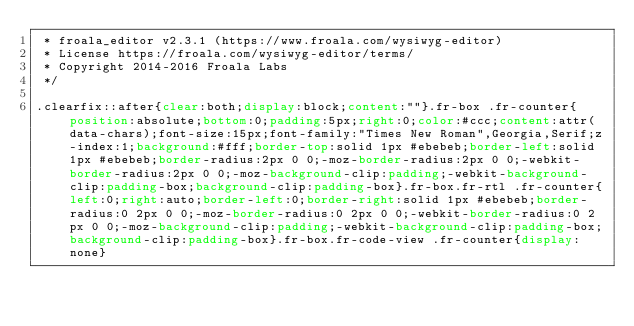<code> <loc_0><loc_0><loc_500><loc_500><_CSS_> * froala_editor v2.3.1 (https://www.froala.com/wysiwyg-editor)
 * License https://froala.com/wysiwyg-editor/terms/
 * Copyright 2014-2016 Froala Labs
 */

.clearfix::after{clear:both;display:block;content:""}.fr-box .fr-counter{position:absolute;bottom:0;padding:5px;right:0;color:#ccc;content:attr(data-chars);font-size:15px;font-family:"Times New Roman",Georgia,Serif;z-index:1;background:#fff;border-top:solid 1px #ebebeb;border-left:solid 1px #ebebeb;border-radius:2px 0 0;-moz-border-radius:2px 0 0;-webkit-border-radius:2px 0 0;-moz-background-clip:padding;-webkit-background-clip:padding-box;background-clip:padding-box}.fr-box.fr-rtl .fr-counter{left:0;right:auto;border-left:0;border-right:solid 1px #ebebeb;border-radius:0 2px 0 0;-moz-border-radius:0 2px 0 0;-webkit-border-radius:0 2px 0 0;-moz-background-clip:padding;-webkit-background-clip:padding-box;background-clip:padding-box}.fr-box.fr-code-view .fr-counter{display:none}</code> 